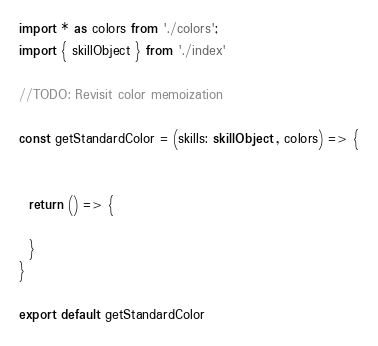<code> <loc_0><loc_0><loc_500><loc_500><_TypeScript_>import * as colors from './colors';
import { skillObject } from './index'

//TODO: Revisit color memoization

const getStandardColor = (skills: skillObject , colors) => {


  return () => {

  }
}

export default getStandardColor</code> 